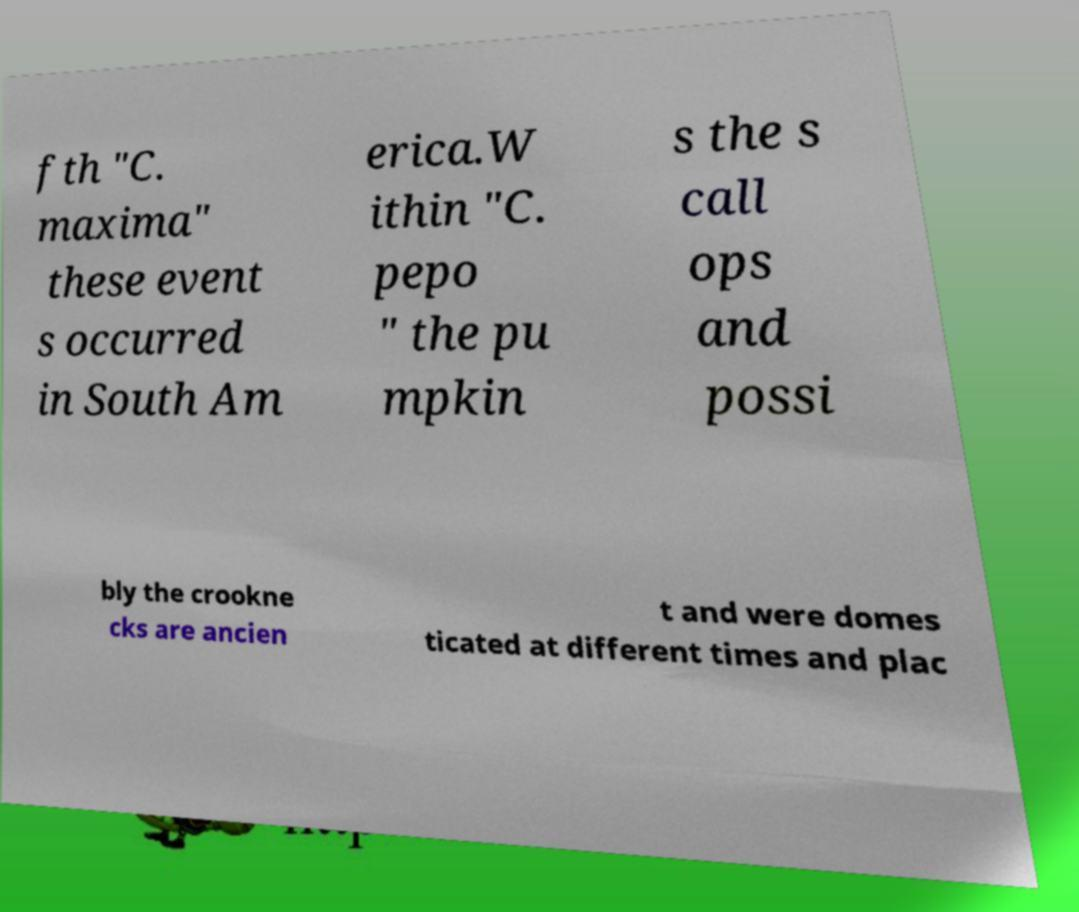Can you accurately transcribe the text from the provided image for me? fth "C. maxima" these event s occurred in South Am erica.W ithin "C. pepo " the pu mpkin s the s call ops and possi bly the crookne cks are ancien t and were domes ticated at different times and plac 